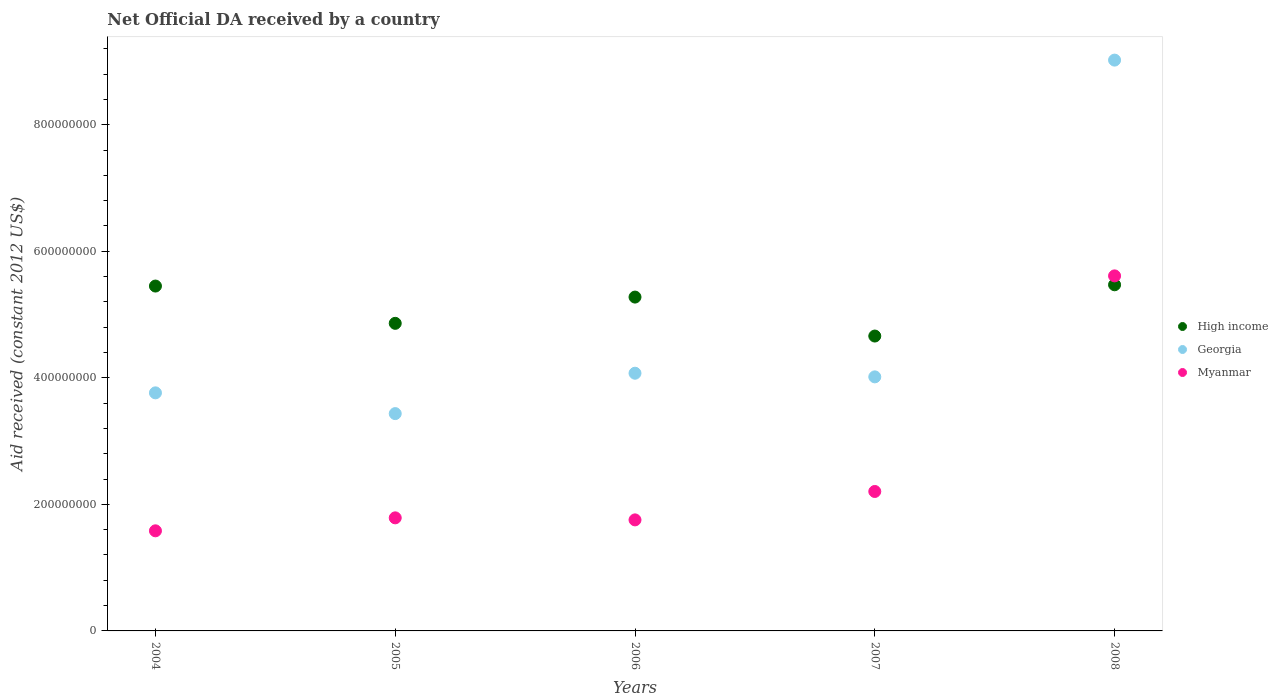Is the number of dotlines equal to the number of legend labels?
Provide a succinct answer. Yes. What is the net official development assistance aid received in Georgia in 2006?
Ensure brevity in your answer.  4.07e+08. Across all years, what is the maximum net official development assistance aid received in Myanmar?
Ensure brevity in your answer.  5.61e+08. Across all years, what is the minimum net official development assistance aid received in High income?
Your response must be concise. 4.66e+08. In which year was the net official development assistance aid received in Georgia maximum?
Keep it short and to the point. 2008. What is the total net official development assistance aid received in High income in the graph?
Provide a short and direct response. 2.57e+09. What is the difference between the net official development assistance aid received in Georgia in 2004 and that in 2005?
Your answer should be compact. 3.28e+07. What is the difference between the net official development assistance aid received in Georgia in 2005 and the net official development assistance aid received in Myanmar in 2008?
Make the answer very short. -2.18e+08. What is the average net official development assistance aid received in Myanmar per year?
Provide a short and direct response. 2.59e+08. In the year 2004, what is the difference between the net official development assistance aid received in High income and net official development assistance aid received in Georgia?
Offer a very short reply. 1.69e+08. What is the ratio of the net official development assistance aid received in High income in 2006 to that in 2008?
Keep it short and to the point. 0.96. Is the difference between the net official development assistance aid received in High income in 2006 and 2008 greater than the difference between the net official development assistance aid received in Georgia in 2006 and 2008?
Your response must be concise. Yes. What is the difference between the highest and the second highest net official development assistance aid received in Myanmar?
Provide a succinct answer. 3.41e+08. What is the difference between the highest and the lowest net official development assistance aid received in High income?
Ensure brevity in your answer.  8.10e+07. Is the net official development assistance aid received in High income strictly less than the net official development assistance aid received in Georgia over the years?
Ensure brevity in your answer.  No. What is the difference between two consecutive major ticks on the Y-axis?
Make the answer very short. 2.00e+08. Are the values on the major ticks of Y-axis written in scientific E-notation?
Provide a succinct answer. No. Where does the legend appear in the graph?
Provide a succinct answer. Center right. How many legend labels are there?
Give a very brief answer. 3. What is the title of the graph?
Provide a succinct answer. Net Official DA received by a country. What is the label or title of the X-axis?
Keep it short and to the point. Years. What is the label or title of the Y-axis?
Give a very brief answer. Aid received (constant 2012 US$). What is the Aid received (constant 2012 US$) of High income in 2004?
Make the answer very short. 5.45e+08. What is the Aid received (constant 2012 US$) of Georgia in 2004?
Offer a very short reply. 3.76e+08. What is the Aid received (constant 2012 US$) in Myanmar in 2004?
Your response must be concise. 1.58e+08. What is the Aid received (constant 2012 US$) in High income in 2005?
Your response must be concise. 4.86e+08. What is the Aid received (constant 2012 US$) of Georgia in 2005?
Your response must be concise. 3.43e+08. What is the Aid received (constant 2012 US$) in Myanmar in 2005?
Provide a short and direct response. 1.79e+08. What is the Aid received (constant 2012 US$) of High income in 2006?
Make the answer very short. 5.28e+08. What is the Aid received (constant 2012 US$) of Georgia in 2006?
Your answer should be very brief. 4.07e+08. What is the Aid received (constant 2012 US$) in Myanmar in 2006?
Your answer should be compact. 1.75e+08. What is the Aid received (constant 2012 US$) in High income in 2007?
Ensure brevity in your answer.  4.66e+08. What is the Aid received (constant 2012 US$) in Georgia in 2007?
Provide a succinct answer. 4.02e+08. What is the Aid received (constant 2012 US$) in Myanmar in 2007?
Provide a succinct answer. 2.20e+08. What is the Aid received (constant 2012 US$) in High income in 2008?
Make the answer very short. 5.47e+08. What is the Aid received (constant 2012 US$) in Georgia in 2008?
Your answer should be compact. 9.02e+08. What is the Aid received (constant 2012 US$) in Myanmar in 2008?
Your answer should be compact. 5.61e+08. Across all years, what is the maximum Aid received (constant 2012 US$) of High income?
Keep it short and to the point. 5.47e+08. Across all years, what is the maximum Aid received (constant 2012 US$) in Georgia?
Provide a succinct answer. 9.02e+08. Across all years, what is the maximum Aid received (constant 2012 US$) of Myanmar?
Your answer should be very brief. 5.61e+08. Across all years, what is the minimum Aid received (constant 2012 US$) of High income?
Your response must be concise. 4.66e+08. Across all years, what is the minimum Aid received (constant 2012 US$) of Georgia?
Offer a terse response. 3.43e+08. Across all years, what is the minimum Aid received (constant 2012 US$) of Myanmar?
Offer a terse response. 1.58e+08. What is the total Aid received (constant 2012 US$) in High income in the graph?
Keep it short and to the point. 2.57e+09. What is the total Aid received (constant 2012 US$) in Georgia in the graph?
Make the answer very short. 2.43e+09. What is the total Aid received (constant 2012 US$) in Myanmar in the graph?
Provide a short and direct response. 1.29e+09. What is the difference between the Aid received (constant 2012 US$) in High income in 2004 and that in 2005?
Provide a short and direct response. 5.89e+07. What is the difference between the Aid received (constant 2012 US$) in Georgia in 2004 and that in 2005?
Ensure brevity in your answer.  3.28e+07. What is the difference between the Aid received (constant 2012 US$) in Myanmar in 2004 and that in 2005?
Provide a short and direct response. -2.05e+07. What is the difference between the Aid received (constant 2012 US$) in High income in 2004 and that in 2006?
Offer a terse response. 1.74e+07. What is the difference between the Aid received (constant 2012 US$) of Georgia in 2004 and that in 2006?
Make the answer very short. -3.10e+07. What is the difference between the Aid received (constant 2012 US$) of Myanmar in 2004 and that in 2006?
Ensure brevity in your answer.  -1.73e+07. What is the difference between the Aid received (constant 2012 US$) of High income in 2004 and that in 2007?
Make the answer very short. 7.90e+07. What is the difference between the Aid received (constant 2012 US$) in Georgia in 2004 and that in 2007?
Offer a very short reply. -2.53e+07. What is the difference between the Aid received (constant 2012 US$) of Myanmar in 2004 and that in 2007?
Provide a succinct answer. -6.22e+07. What is the difference between the Aid received (constant 2012 US$) of High income in 2004 and that in 2008?
Provide a short and direct response. -2.02e+06. What is the difference between the Aid received (constant 2012 US$) of Georgia in 2004 and that in 2008?
Keep it short and to the point. -5.26e+08. What is the difference between the Aid received (constant 2012 US$) of Myanmar in 2004 and that in 2008?
Your response must be concise. -4.03e+08. What is the difference between the Aid received (constant 2012 US$) of High income in 2005 and that in 2006?
Provide a succinct answer. -4.15e+07. What is the difference between the Aid received (constant 2012 US$) in Georgia in 2005 and that in 2006?
Your answer should be compact. -6.38e+07. What is the difference between the Aid received (constant 2012 US$) of Myanmar in 2005 and that in 2006?
Give a very brief answer. 3.22e+06. What is the difference between the Aid received (constant 2012 US$) of High income in 2005 and that in 2007?
Your answer should be compact. 2.01e+07. What is the difference between the Aid received (constant 2012 US$) of Georgia in 2005 and that in 2007?
Provide a succinct answer. -5.81e+07. What is the difference between the Aid received (constant 2012 US$) of Myanmar in 2005 and that in 2007?
Give a very brief answer. -4.17e+07. What is the difference between the Aid received (constant 2012 US$) of High income in 2005 and that in 2008?
Keep it short and to the point. -6.09e+07. What is the difference between the Aid received (constant 2012 US$) in Georgia in 2005 and that in 2008?
Keep it short and to the point. -5.59e+08. What is the difference between the Aid received (constant 2012 US$) of Myanmar in 2005 and that in 2008?
Offer a very short reply. -3.82e+08. What is the difference between the Aid received (constant 2012 US$) of High income in 2006 and that in 2007?
Ensure brevity in your answer.  6.16e+07. What is the difference between the Aid received (constant 2012 US$) in Georgia in 2006 and that in 2007?
Make the answer very short. 5.75e+06. What is the difference between the Aid received (constant 2012 US$) in Myanmar in 2006 and that in 2007?
Make the answer very short. -4.49e+07. What is the difference between the Aid received (constant 2012 US$) in High income in 2006 and that in 2008?
Ensure brevity in your answer.  -1.94e+07. What is the difference between the Aid received (constant 2012 US$) in Georgia in 2006 and that in 2008?
Make the answer very short. -4.95e+08. What is the difference between the Aid received (constant 2012 US$) in Myanmar in 2006 and that in 2008?
Your answer should be very brief. -3.86e+08. What is the difference between the Aid received (constant 2012 US$) of High income in 2007 and that in 2008?
Your response must be concise. -8.10e+07. What is the difference between the Aid received (constant 2012 US$) of Georgia in 2007 and that in 2008?
Your answer should be very brief. -5.01e+08. What is the difference between the Aid received (constant 2012 US$) of Myanmar in 2007 and that in 2008?
Offer a very short reply. -3.41e+08. What is the difference between the Aid received (constant 2012 US$) of High income in 2004 and the Aid received (constant 2012 US$) of Georgia in 2005?
Provide a short and direct response. 2.02e+08. What is the difference between the Aid received (constant 2012 US$) of High income in 2004 and the Aid received (constant 2012 US$) of Myanmar in 2005?
Your answer should be compact. 3.66e+08. What is the difference between the Aid received (constant 2012 US$) of Georgia in 2004 and the Aid received (constant 2012 US$) of Myanmar in 2005?
Your answer should be compact. 1.98e+08. What is the difference between the Aid received (constant 2012 US$) of High income in 2004 and the Aid received (constant 2012 US$) of Georgia in 2006?
Offer a very short reply. 1.38e+08. What is the difference between the Aid received (constant 2012 US$) of High income in 2004 and the Aid received (constant 2012 US$) of Myanmar in 2006?
Ensure brevity in your answer.  3.70e+08. What is the difference between the Aid received (constant 2012 US$) in Georgia in 2004 and the Aid received (constant 2012 US$) in Myanmar in 2006?
Your answer should be compact. 2.01e+08. What is the difference between the Aid received (constant 2012 US$) of High income in 2004 and the Aid received (constant 2012 US$) of Georgia in 2007?
Give a very brief answer. 1.44e+08. What is the difference between the Aid received (constant 2012 US$) of High income in 2004 and the Aid received (constant 2012 US$) of Myanmar in 2007?
Offer a terse response. 3.25e+08. What is the difference between the Aid received (constant 2012 US$) of Georgia in 2004 and the Aid received (constant 2012 US$) of Myanmar in 2007?
Offer a very short reply. 1.56e+08. What is the difference between the Aid received (constant 2012 US$) in High income in 2004 and the Aid received (constant 2012 US$) in Georgia in 2008?
Keep it short and to the point. -3.57e+08. What is the difference between the Aid received (constant 2012 US$) in High income in 2004 and the Aid received (constant 2012 US$) in Myanmar in 2008?
Provide a succinct answer. -1.61e+07. What is the difference between the Aid received (constant 2012 US$) of Georgia in 2004 and the Aid received (constant 2012 US$) of Myanmar in 2008?
Your answer should be very brief. -1.85e+08. What is the difference between the Aid received (constant 2012 US$) in High income in 2005 and the Aid received (constant 2012 US$) in Georgia in 2006?
Give a very brief answer. 7.88e+07. What is the difference between the Aid received (constant 2012 US$) of High income in 2005 and the Aid received (constant 2012 US$) of Myanmar in 2006?
Make the answer very short. 3.11e+08. What is the difference between the Aid received (constant 2012 US$) of Georgia in 2005 and the Aid received (constant 2012 US$) of Myanmar in 2006?
Keep it short and to the point. 1.68e+08. What is the difference between the Aid received (constant 2012 US$) of High income in 2005 and the Aid received (constant 2012 US$) of Georgia in 2007?
Your response must be concise. 8.46e+07. What is the difference between the Aid received (constant 2012 US$) of High income in 2005 and the Aid received (constant 2012 US$) of Myanmar in 2007?
Your answer should be compact. 2.66e+08. What is the difference between the Aid received (constant 2012 US$) of Georgia in 2005 and the Aid received (constant 2012 US$) of Myanmar in 2007?
Your answer should be very brief. 1.23e+08. What is the difference between the Aid received (constant 2012 US$) of High income in 2005 and the Aid received (constant 2012 US$) of Georgia in 2008?
Provide a short and direct response. -4.16e+08. What is the difference between the Aid received (constant 2012 US$) of High income in 2005 and the Aid received (constant 2012 US$) of Myanmar in 2008?
Provide a short and direct response. -7.50e+07. What is the difference between the Aid received (constant 2012 US$) in Georgia in 2005 and the Aid received (constant 2012 US$) in Myanmar in 2008?
Ensure brevity in your answer.  -2.18e+08. What is the difference between the Aid received (constant 2012 US$) of High income in 2006 and the Aid received (constant 2012 US$) of Georgia in 2007?
Your answer should be compact. 1.26e+08. What is the difference between the Aid received (constant 2012 US$) in High income in 2006 and the Aid received (constant 2012 US$) in Myanmar in 2007?
Offer a very short reply. 3.07e+08. What is the difference between the Aid received (constant 2012 US$) of Georgia in 2006 and the Aid received (constant 2012 US$) of Myanmar in 2007?
Provide a succinct answer. 1.87e+08. What is the difference between the Aid received (constant 2012 US$) of High income in 2006 and the Aid received (constant 2012 US$) of Georgia in 2008?
Give a very brief answer. -3.75e+08. What is the difference between the Aid received (constant 2012 US$) in High income in 2006 and the Aid received (constant 2012 US$) in Myanmar in 2008?
Make the answer very short. -3.35e+07. What is the difference between the Aid received (constant 2012 US$) in Georgia in 2006 and the Aid received (constant 2012 US$) in Myanmar in 2008?
Offer a terse response. -1.54e+08. What is the difference between the Aid received (constant 2012 US$) of High income in 2007 and the Aid received (constant 2012 US$) of Georgia in 2008?
Keep it short and to the point. -4.36e+08. What is the difference between the Aid received (constant 2012 US$) in High income in 2007 and the Aid received (constant 2012 US$) in Myanmar in 2008?
Provide a short and direct response. -9.51e+07. What is the difference between the Aid received (constant 2012 US$) in Georgia in 2007 and the Aid received (constant 2012 US$) in Myanmar in 2008?
Offer a very short reply. -1.60e+08. What is the average Aid received (constant 2012 US$) in High income per year?
Your answer should be very brief. 5.14e+08. What is the average Aid received (constant 2012 US$) of Georgia per year?
Make the answer very short. 4.86e+08. What is the average Aid received (constant 2012 US$) in Myanmar per year?
Offer a very short reply. 2.59e+08. In the year 2004, what is the difference between the Aid received (constant 2012 US$) in High income and Aid received (constant 2012 US$) in Georgia?
Provide a succinct answer. 1.69e+08. In the year 2004, what is the difference between the Aid received (constant 2012 US$) in High income and Aid received (constant 2012 US$) in Myanmar?
Your response must be concise. 3.87e+08. In the year 2004, what is the difference between the Aid received (constant 2012 US$) of Georgia and Aid received (constant 2012 US$) of Myanmar?
Your answer should be very brief. 2.18e+08. In the year 2005, what is the difference between the Aid received (constant 2012 US$) of High income and Aid received (constant 2012 US$) of Georgia?
Offer a terse response. 1.43e+08. In the year 2005, what is the difference between the Aid received (constant 2012 US$) in High income and Aid received (constant 2012 US$) in Myanmar?
Your answer should be compact. 3.07e+08. In the year 2005, what is the difference between the Aid received (constant 2012 US$) of Georgia and Aid received (constant 2012 US$) of Myanmar?
Offer a terse response. 1.65e+08. In the year 2006, what is the difference between the Aid received (constant 2012 US$) of High income and Aid received (constant 2012 US$) of Georgia?
Keep it short and to the point. 1.20e+08. In the year 2006, what is the difference between the Aid received (constant 2012 US$) in High income and Aid received (constant 2012 US$) in Myanmar?
Your response must be concise. 3.52e+08. In the year 2006, what is the difference between the Aid received (constant 2012 US$) in Georgia and Aid received (constant 2012 US$) in Myanmar?
Ensure brevity in your answer.  2.32e+08. In the year 2007, what is the difference between the Aid received (constant 2012 US$) in High income and Aid received (constant 2012 US$) in Georgia?
Provide a succinct answer. 6.45e+07. In the year 2007, what is the difference between the Aid received (constant 2012 US$) in High income and Aid received (constant 2012 US$) in Myanmar?
Give a very brief answer. 2.46e+08. In the year 2007, what is the difference between the Aid received (constant 2012 US$) of Georgia and Aid received (constant 2012 US$) of Myanmar?
Offer a terse response. 1.81e+08. In the year 2008, what is the difference between the Aid received (constant 2012 US$) of High income and Aid received (constant 2012 US$) of Georgia?
Your answer should be compact. -3.55e+08. In the year 2008, what is the difference between the Aid received (constant 2012 US$) of High income and Aid received (constant 2012 US$) of Myanmar?
Your answer should be compact. -1.41e+07. In the year 2008, what is the difference between the Aid received (constant 2012 US$) in Georgia and Aid received (constant 2012 US$) in Myanmar?
Provide a succinct answer. 3.41e+08. What is the ratio of the Aid received (constant 2012 US$) of High income in 2004 to that in 2005?
Your answer should be compact. 1.12. What is the ratio of the Aid received (constant 2012 US$) of Georgia in 2004 to that in 2005?
Offer a very short reply. 1.1. What is the ratio of the Aid received (constant 2012 US$) of Myanmar in 2004 to that in 2005?
Make the answer very short. 0.89. What is the ratio of the Aid received (constant 2012 US$) of High income in 2004 to that in 2006?
Offer a very short reply. 1.03. What is the ratio of the Aid received (constant 2012 US$) in Georgia in 2004 to that in 2006?
Provide a short and direct response. 0.92. What is the ratio of the Aid received (constant 2012 US$) of Myanmar in 2004 to that in 2006?
Keep it short and to the point. 0.9. What is the ratio of the Aid received (constant 2012 US$) in High income in 2004 to that in 2007?
Your response must be concise. 1.17. What is the ratio of the Aid received (constant 2012 US$) of Georgia in 2004 to that in 2007?
Keep it short and to the point. 0.94. What is the ratio of the Aid received (constant 2012 US$) of Myanmar in 2004 to that in 2007?
Offer a terse response. 0.72. What is the ratio of the Aid received (constant 2012 US$) in High income in 2004 to that in 2008?
Keep it short and to the point. 1. What is the ratio of the Aid received (constant 2012 US$) of Georgia in 2004 to that in 2008?
Provide a succinct answer. 0.42. What is the ratio of the Aid received (constant 2012 US$) of Myanmar in 2004 to that in 2008?
Provide a succinct answer. 0.28. What is the ratio of the Aid received (constant 2012 US$) in High income in 2005 to that in 2006?
Your answer should be very brief. 0.92. What is the ratio of the Aid received (constant 2012 US$) of Georgia in 2005 to that in 2006?
Your answer should be very brief. 0.84. What is the ratio of the Aid received (constant 2012 US$) of Myanmar in 2005 to that in 2006?
Your answer should be compact. 1.02. What is the ratio of the Aid received (constant 2012 US$) in High income in 2005 to that in 2007?
Your response must be concise. 1.04. What is the ratio of the Aid received (constant 2012 US$) in Georgia in 2005 to that in 2007?
Your answer should be very brief. 0.86. What is the ratio of the Aid received (constant 2012 US$) in Myanmar in 2005 to that in 2007?
Your answer should be compact. 0.81. What is the ratio of the Aid received (constant 2012 US$) in High income in 2005 to that in 2008?
Your response must be concise. 0.89. What is the ratio of the Aid received (constant 2012 US$) in Georgia in 2005 to that in 2008?
Provide a short and direct response. 0.38. What is the ratio of the Aid received (constant 2012 US$) of Myanmar in 2005 to that in 2008?
Provide a short and direct response. 0.32. What is the ratio of the Aid received (constant 2012 US$) in High income in 2006 to that in 2007?
Give a very brief answer. 1.13. What is the ratio of the Aid received (constant 2012 US$) of Georgia in 2006 to that in 2007?
Provide a short and direct response. 1.01. What is the ratio of the Aid received (constant 2012 US$) in Myanmar in 2006 to that in 2007?
Offer a very short reply. 0.8. What is the ratio of the Aid received (constant 2012 US$) in High income in 2006 to that in 2008?
Ensure brevity in your answer.  0.96. What is the ratio of the Aid received (constant 2012 US$) of Georgia in 2006 to that in 2008?
Ensure brevity in your answer.  0.45. What is the ratio of the Aid received (constant 2012 US$) in Myanmar in 2006 to that in 2008?
Your response must be concise. 0.31. What is the ratio of the Aid received (constant 2012 US$) in High income in 2007 to that in 2008?
Give a very brief answer. 0.85. What is the ratio of the Aid received (constant 2012 US$) of Georgia in 2007 to that in 2008?
Your answer should be very brief. 0.45. What is the ratio of the Aid received (constant 2012 US$) in Myanmar in 2007 to that in 2008?
Offer a terse response. 0.39. What is the difference between the highest and the second highest Aid received (constant 2012 US$) in High income?
Your answer should be very brief. 2.02e+06. What is the difference between the highest and the second highest Aid received (constant 2012 US$) of Georgia?
Your response must be concise. 4.95e+08. What is the difference between the highest and the second highest Aid received (constant 2012 US$) in Myanmar?
Your answer should be compact. 3.41e+08. What is the difference between the highest and the lowest Aid received (constant 2012 US$) in High income?
Offer a very short reply. 8.10e+07. What is the difference between the highest and the lowest Aid received (constant 2012 US$) of Georgia?
Make the answer very short. 5.59e+08. What is the difference between the highest and the lowest Aid received (constant 2012 US$) in Myanmar?
Your answer should be compact. 4.03e+08. 